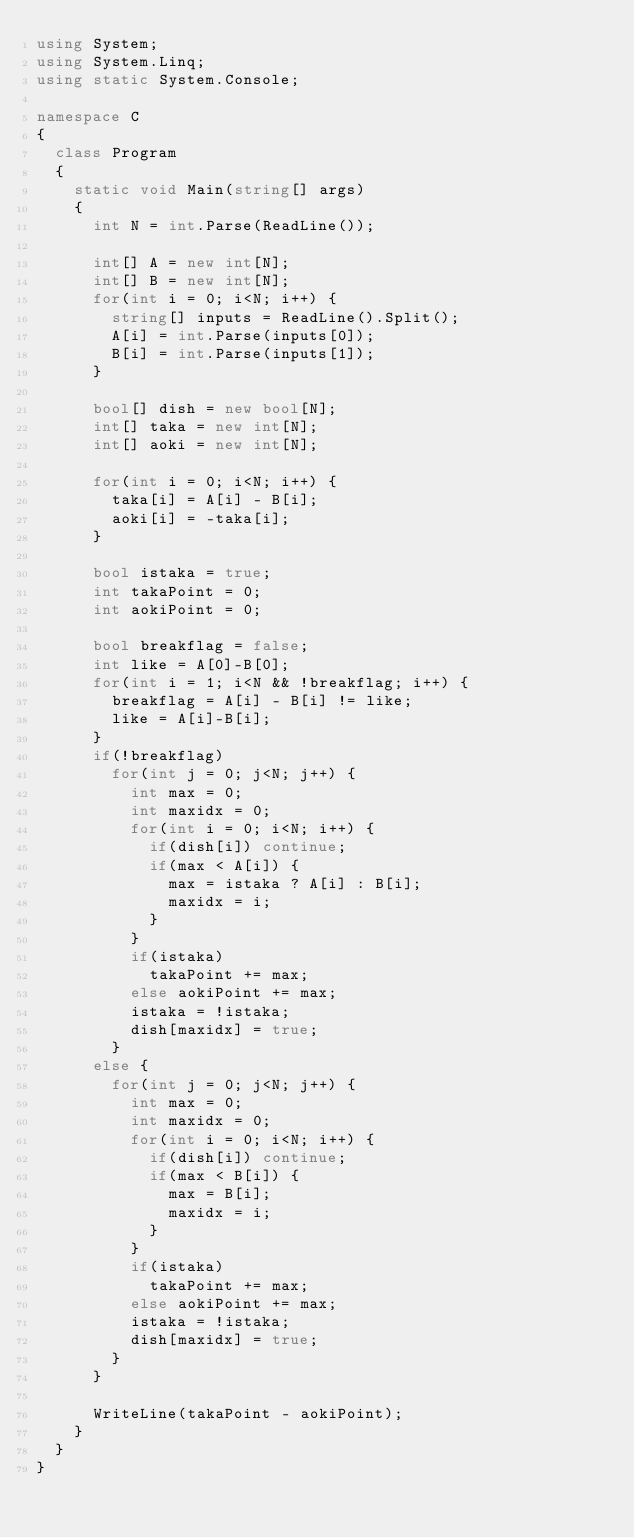Convert code to text. <code><loc_0><loc_0><loc_500><loc_500><_C#_>using System;
using System.Linq;
using static System.Console;

namespace C
{
  class Program
  {
    static void Main(string[] args)
    {
      int N = int.Parse(ReadLine());

      int[] A = new int[N];
      int[] B = new int[N];
      for(int i = 0; i<N; i++) {
        string[] inputs = ReadLine().Split();
        A[i] = int.Parse(inputs[0]);
        B[i] = int.Parse(inputs[1]);
      }

      bool[] dish = new bool[N];
      int[] taka = new int[N];
      int[] aoki = new int[N];

      for(int i = 0; i<N; i++) {
        taka[i] = A[i] - B[i];
        aoki[i] = -taka[i];
      }

      bool istaka = true;
      int takaPoint = 0;
      int aokiPoint = 0;

      bool breakflag = false;
      int like = A[0]-B[0];
      for(int i = 1; i<N && !breakflag; i++) {
        breakflag = A[i] - B[i] != like;
        like = A[i]-B[i];
      }
      if(!breakflag)
        for(int j = 0; j<N; j++) {
          int max = 0;
          int maxidx = 0;
          for(int i = 0; i<N; i++) {
            if(dish[i]) continue;
            if(max < A[i]) {
              max = istaka ? A[i] : B[i];
              maxidx = i;
            }
          }
          if(istaka)
            takaPoint += max;
          else aokiPoint += max;
          istaka = !istaka;
          dish[maxidx] = true;
        }
      else {
        for(int j = 0; j<N; j++) {
          int max = 0;
          int maxidx = 0;
          for(int i = 0; i<N; i++) {
            if(dish[i]) continue;
            if(max < B[i]) {
              max = B[i];
              maxidx = i;
            }
          }
          if(istaka)
            takaPoint += max;
          else aokiPoint += max;
          istaka = !istaka;
          dish[maxidx] = true;
        }
      }

      WriteLine(takaPoint - aokiPoint);
    }
  }
}
</code> 